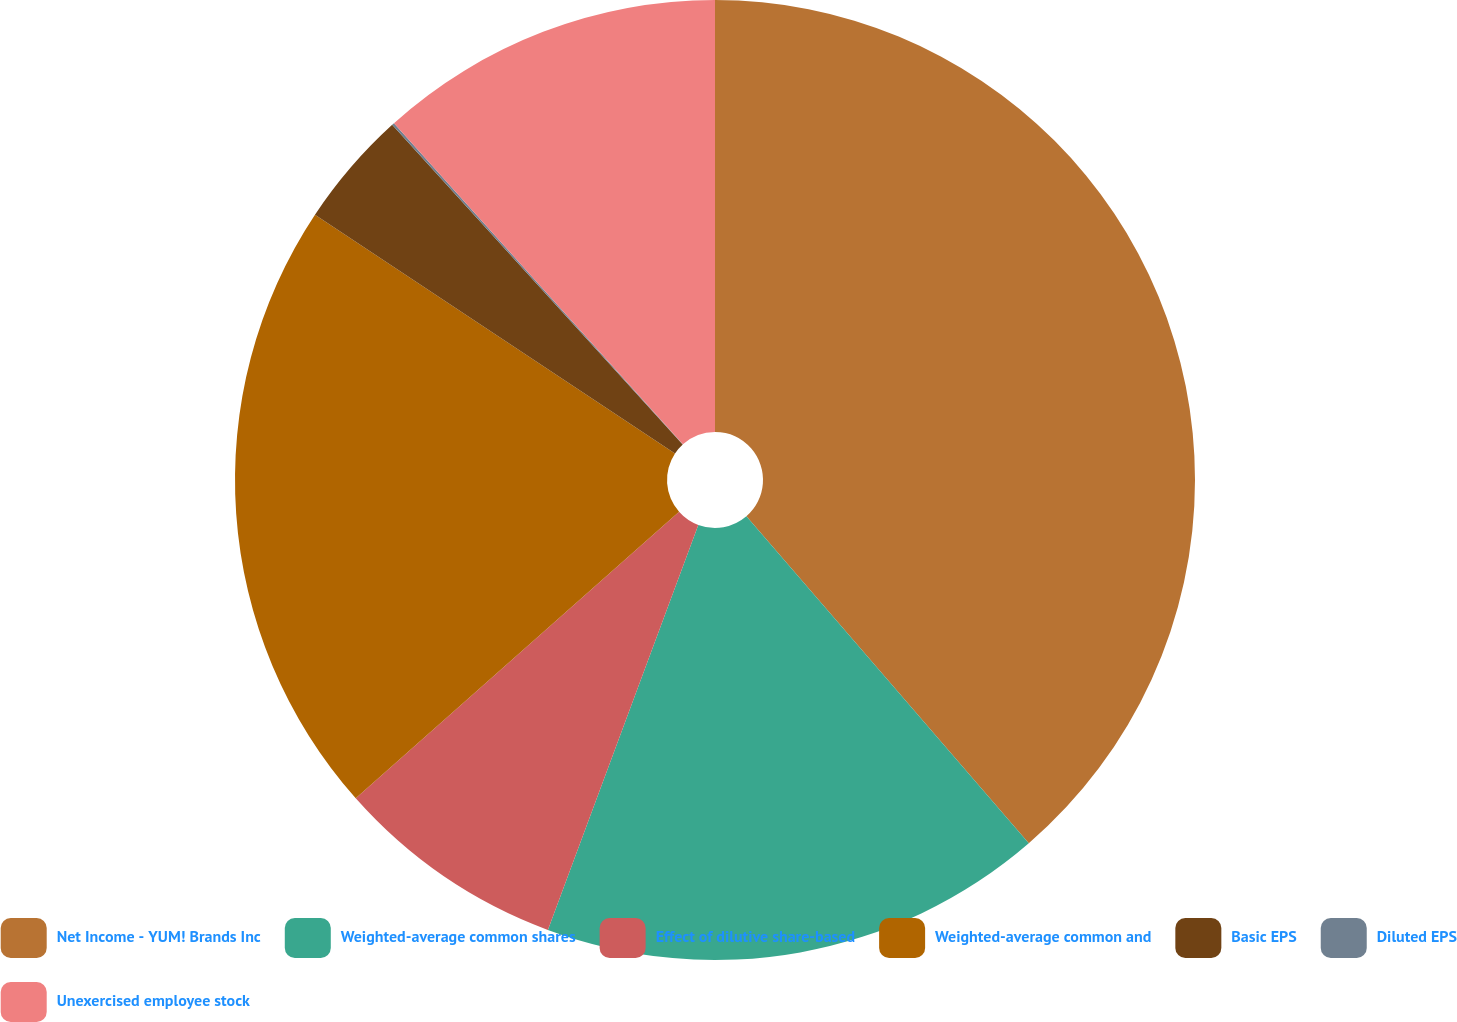Convert chart to OTSL. <chart><loc_0><loc_0><loc_500><loc_500><pie_chart><fcel>Net Income - YUM! Brands Inc<fcel>Weighted-average common shares<fcel>Effect of dilutive share-based<fcel>Weighted-average common and<fcel>Basic EPS<fcel>Diluted EPS<fcel>Unexercised employee stock<nl><fcel>38.66%<fcel>17.0%<fcel>7.8%<fcel>20.86%<fcel>3.94%<fcel>0.08%<fcel>11.66%<nl></chart> 